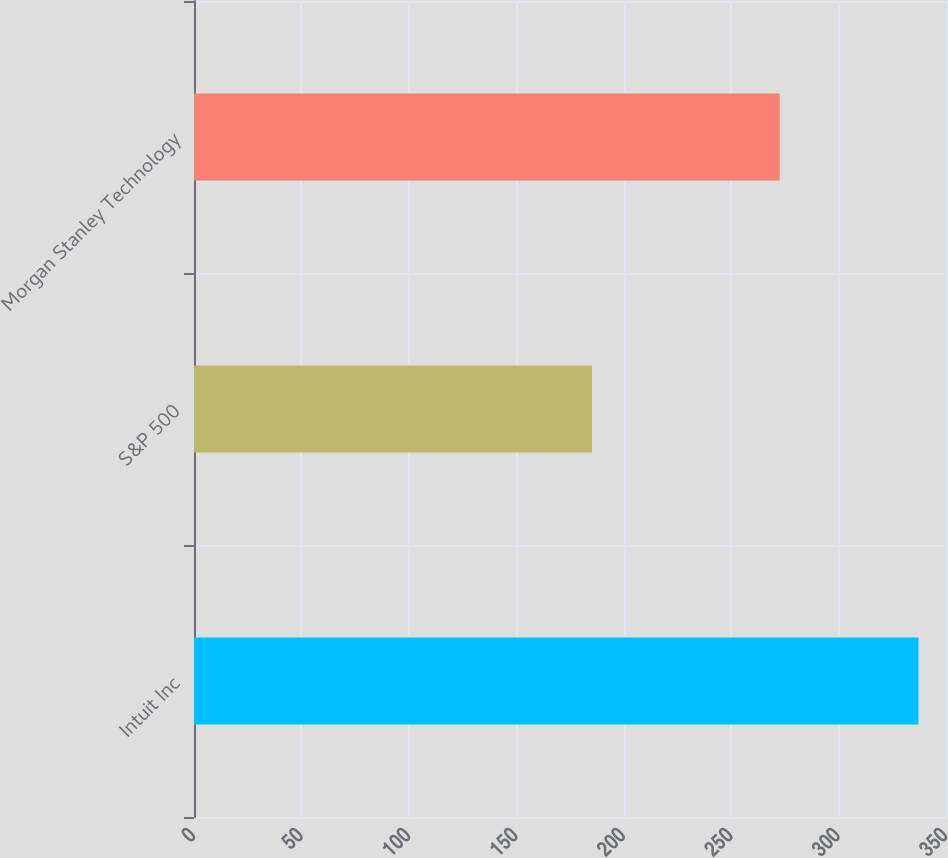Convert chart. <chart><loc_0><loc_0><loc_500><loc_500><bar_chart><fcel>Intuit Inc<fcel>S&P 500<fcel>Morgan Stanley Technology<nl><fcel>337.16<fcel>185.26<fcel>272.62<nl></chart> 